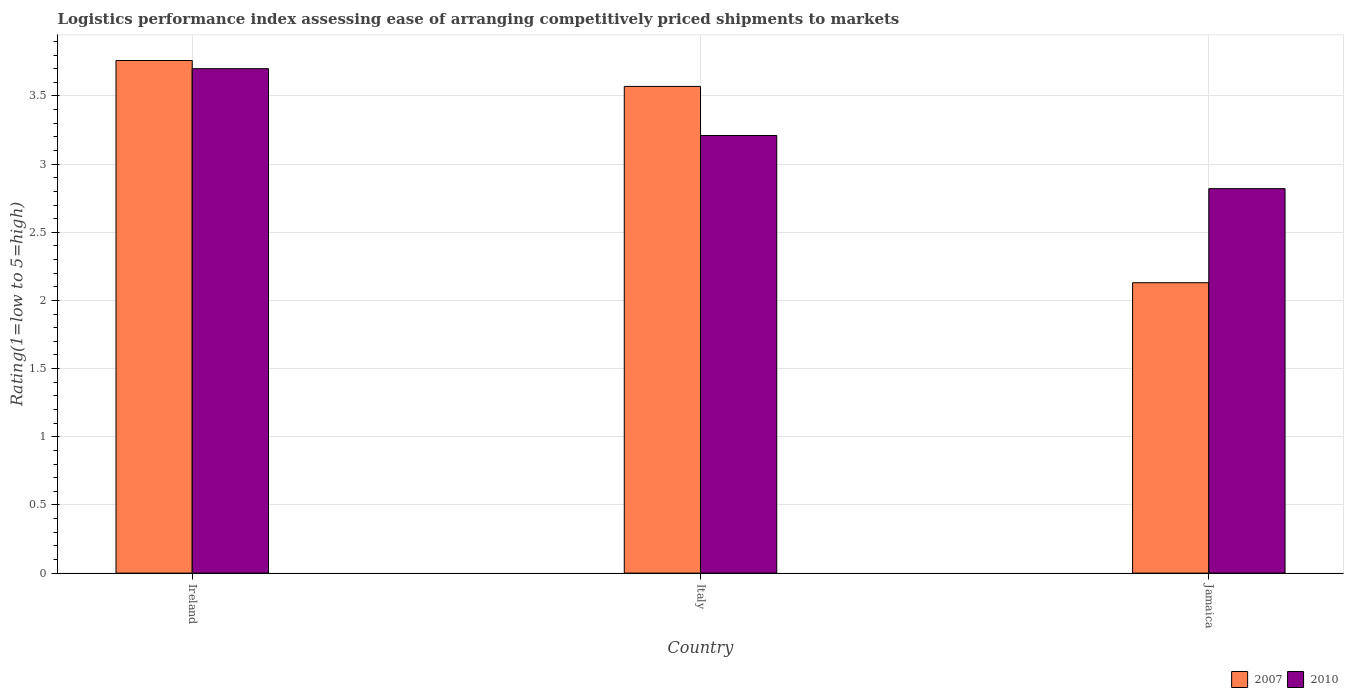How many groups of bars are there?
Give a very brief answer. 3. Are the number of bars on each tick of the X-axis equal?
Your answer should be very brief. Yes. What is the label of the 3rd group of bars from the left?
Your response must be concise. Jamaica. What is the Logistic performance index in 2007 in Italy?
Make the answer very short. 3.57. Across all countries, what is the minimum Logistic performance index in 2010?
Your answer should be very brief. 2.82. In which country was the Logistic performance index in 2010 maximum?
Your answer should be compact. Ireland. In which country was the Logistic performance index in 2010 minimum?
Provide a short and direct response. Jamaica. What is the total Logistic performance index in 2007 in the graph?
Ensure brevity in your answer.  9.46. What is the difference between the Logistic performance index in 2010 in Ireland and that in Jamaica?
Offer a very short reply. 0.88. What is the difference between the Logistic performance index in 2007 in Jamaica and the Logistic performance index in 2010 in Italy?
Make the answer very short. -1.08. What is the average Logistic performance index in 2010 per country?
Your answer should be very brief. 3.24. What is the difference between the Logistic performance index of/in 2010 and Logistic performance index of/in 2007 in Ireland?
Give a very brief answer. -0.06. In how many countries, is the Logistic performance index in 2007 greater than 2?
Your response must be concise. 3. What is the ratio of the Logistic performance index in 2007 in Ireland to that in Italy?
Give a very brief answer. 1.05. Is the Logistic performance index in 2007 in Italy less than that in Jamaica?
Ensure brevity in your answer.  No. Is the difference between the Logistic performance index in 2010 in Ireland and Italy greater than the difference between the Logistic performance index in 2007 in Ireland and Italy?
Provide a succinct answer. Yes. What is the difference between the highest and the second highest Logistic performance index in 2007?
Your answer should be compact. 1.44. What is the difference between the highest and the lowest Logistic performance index in 2010?
Your response must be concise. 0.88. What does the 1st bar from the left in Italy represents?
Your answer should be compact. 2007. How many bars are there?
Ensure brevity in your answer.  6. What is the difference between two consecutive major ticks on the Y-axis?
Ensure brevity in your answer.  0.5. Does the graph contain grids?
Make the answer very short. Yes. Where does the legend appear in the graph?
Provide a succinct answer. Bottom right. What is the title of the graph?
Make the answer very short. Logistics performance index assessing ease of arranging competitively priced shipments to markets. What is the label or title of the Y-axis?
Ensure brevity in your answer.  Rating(1=low to 5=high). What is the Rating(1=low to 5=high) of 2007 in Ireland?
Offer a very short reply. 3.76. What is the Rating(1=low to 5=high) of 2010 in Ireland?
Give a very brief answer. 3.7. What is the Rating(1=low to 5=high) in 2007 in Italy?
Provide a succinct answer. 3.57. What is the Rating(1=low to 5=high) in 2010 in Italy?
Make the answer very short. 3.21. What is the Rating(1=low to 5=high) of 2007 in Jamaica?
Offer a very short reply. 2.13. What is the Rating(1=low to 5=high) of 2010 in Jamaica?
Ensure brevity in your answer.  2.82. Across all countries, what is the maximum Rating(1=low to 5=high) in 2007?
Offer a very short reply. 3.76. Across all countries, what is the minimum Rating(1=low to 5=high) of 2007?
Your response must be concise. 2.13. Across all countries, what is the minimum Rating(1=low to 5=high) in 2010?
Your answer should be very brief. 2.82. What is the total Rating(1=low to 5=high) in 2007 in the graph?
Your answer should be compact. 9.46. What is the total Rating(1=low to 5=high) of 2010 in the graph?
Your response must be concise. 9.73. What is the difference between the Rating(1=low to 5=high) in 2007 in Ireland and that in Italy?
Give a very brief answer. 0.19. What is the difference between the Rating(1=low to 5=high) in 2010 in Ireland and that in Italy?
Your response must be concise. 0.49. What is the difference between the Rating(1=low to 5=high) in 2007 in Ireland and that in Jamaica?
Your answer should be very brief. 1.63. What is the difference between the Rating(1=low to 5=high) of 2007 in Italy and that in Jamaica?
Make the answer very short. 1.44. What is the difference between the Rating(1=low to 5=high) in 2010 in Italy and that in Jamaica?
Your answer should be compact. 0.39. What is the difference between the Rating(1=low to 5=high) in 2007 in Ireland and the Rating(1=low to 5=high) in 2010 in Italy?
Make the answer very short. 0.55. What is the difference between the Rating(1=low to 5=high) in 2007 in Ireland and the Rating(1=low to 5=high) in 2010 in Jamaica?
Provide a short and direct response. 0.94. What is the average Rating(1=low to 5=high) of 2007 per country?
Make the answer very short. 3.15. What is the average Rating(1=low to 5=high) of 2010 per country?
Keep it short and to the point. 3.24. What is the difference between the Rating(1=low to 5=high) in 2007 and Rating(1=low to 5=high) in 2010 in Italy?
Make the answer very short. 0.36. What is the difference between the Rating(1=low to 5=high) of 2007 and Rating(1=low to 5=high) of 2010 in Jamaica?
Your answer should be very brief. -0.69. What is the ratio of the Rating(1=low to 5=high) in 2007 in Ireland to that in Italy?
Provide a short and direct response. 1.05. What is the ratio of the Rating(1=low to 5=high) of 2010 in Ireland to that in Italy?
Your answer should be very brief. 1.15. What is the ratio of the Rating(1=low to 5=high) of 2007 in Ireland to that in Jamaica?
Your answer should be very brief. 1.77. What is the ratio of the Rating(1=low to 5=high) in 2010 in Ireland to that in Jamaica?
Offer a terse response. 1.31. What is the ratio of the Rating(1=low to 5=high) in 2007 in Italy to that in Jamaica?
Your answer should be compact. 1.68. What is the ratio of the Rating(1=low to 5=high) of 2010 in Italy to that in Jamaica?
Ensure brevity in your answer.  1.14. What is the difference between the highest and the second highest Rating(1=low to 5=high) in 2007?
Provide a succinct answer. 0.19. What is the difference between the highest and the second highest Rating(1=low to 5=high) in 2010?
Give a very brief answer. 0.49. What is the difference between the highest and the lowest Rating(1=low to 5=high) of 2007?
Keep it short and to the point. 1.63. 